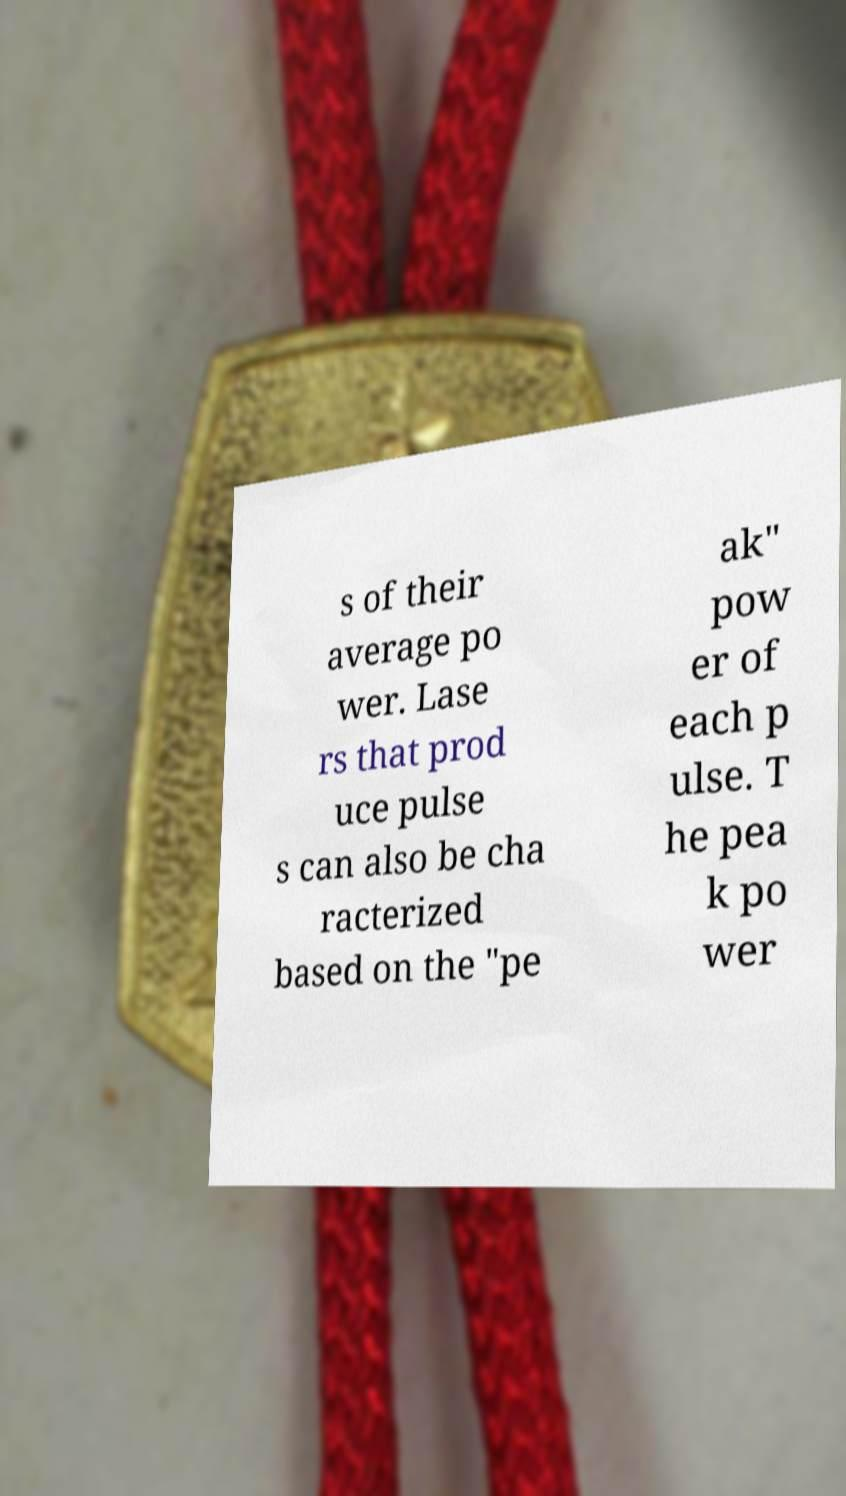Please read and relay the text visible in this image. What does it say? s of their average po wer. Lase rs that prod uce pulse s can also be cha racterized based on the "pe ak" pow er of each p ulse. T he pea k po wer 